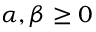<formula> <loc_0><loc_0><loc_500><loc_500>\alpha , \beta \geq 0</formula> 